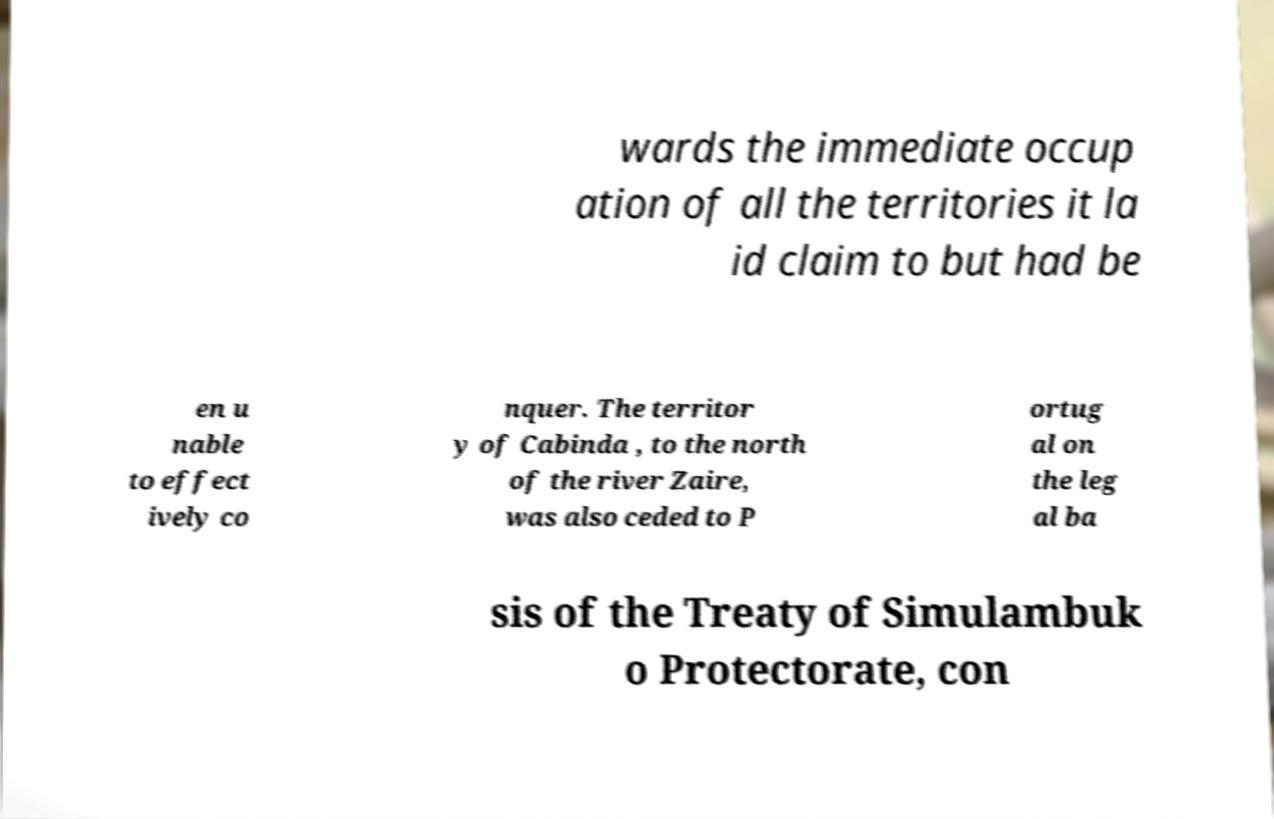Could you extract and type out the text from this image? wards the immediate occup ation of all the territories it la id claim to but had be en u nable to effect ively co nquer. The territor y of Cabinda , to the north of the river Zaire, was also ceded to P ortug al on the leg al ba sis of the Treaty of Simulambuk o Protectorate, con 